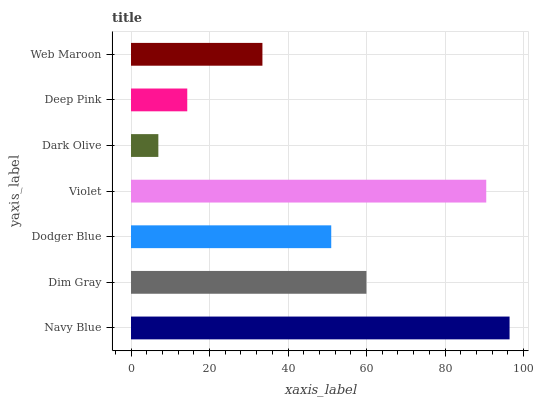Is Dark Olive the minimum?
Answer yes or no. Yes. Is Navy Blue the maximum?
Answer yes or no. Yes. Is Dim Gray the minimum?
Answer yes or no. No. Is Dim Gray the maximum?
Answer yes or no. No. Is Navy Blue greater than Dim Gray?
Answer yes or no. Yes. Is Dim Gray less than Navy Blue?
Answer yes or no. Yes. Is Dim Gray greater than Navy Blue?
Answer yes or no. No. Is Navy Blue less than Dim Gray?
Answer yes or no. No. Is Dodger Blue the high median?
Answer yes or no. Yes. Is Dodger Blue the low median?
Answer yes or no. Yes. Is Deep Pink the high median?
Answer yes or no. No. Is Violet the low median?
Answer yes or no. No. 